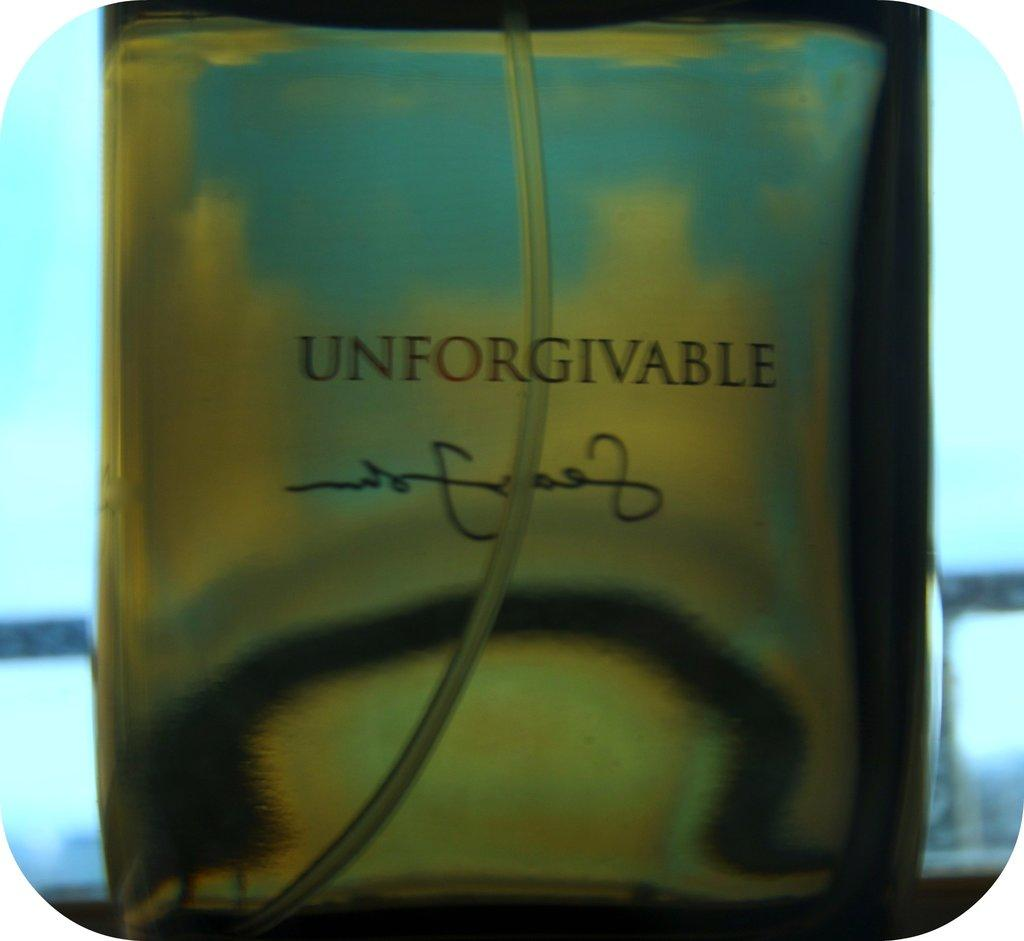<image>
Create a compact narrative representing the image presented. a bottle of Unforgiveable perfume with a window behind it 